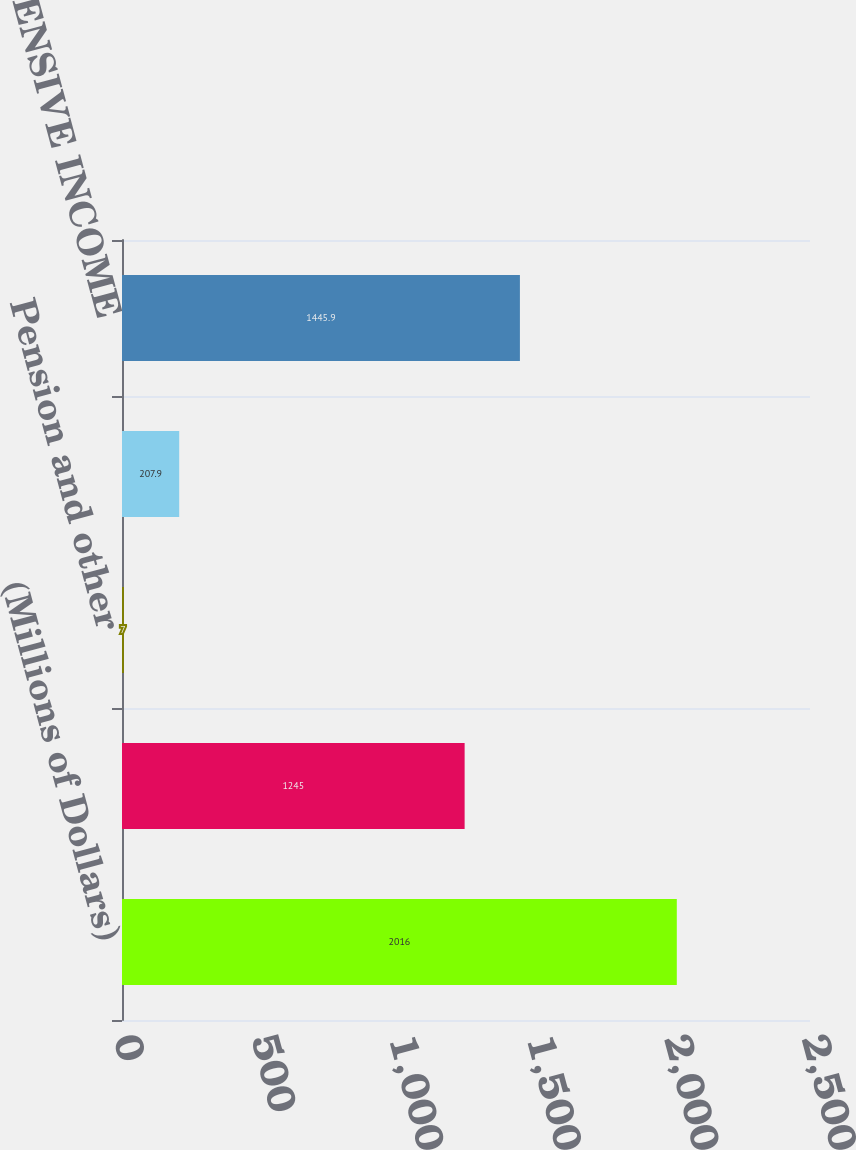Convert chart. <chart><loc_0><loc_0><loc_500><loc_500><bar_chart><fcel>(Millions of Dollars)<fcel>NET INCOME<fcel>Pension and other<fcel>TOTAL OTHER COMPREHENSIVE<fcel>COMPREHENSIVE INCOME<nl><fcel>2016<fcel>1245<fcel>7<fcel>207.9<fcel>1445.9<nl></chart> 